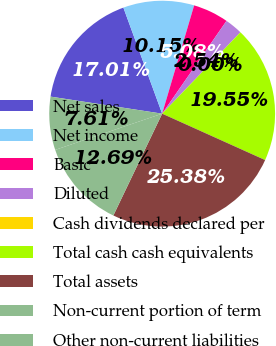Convert chart to OTSL. <chart><loc_0><loc_0><loc_500><loc_500><pie_chart><fcel>Net sales<fcel>Net income<fcel>Basic<fcel>Diluted<fcel>Cash dividends declared per<fcel>Total cash cash equivalents<fcel>Total assets<fcel>Non-current portion of term<fcel>Other non-current liabilities<nl><fcel>17.01%<fcel>10.15%<fcel>5.08%<fcel>2.54%<fcel>0.0%<fcel>19.55%<fcel>25.38%<fcel>12.69%<fcel>7.61%<nl></chart> 